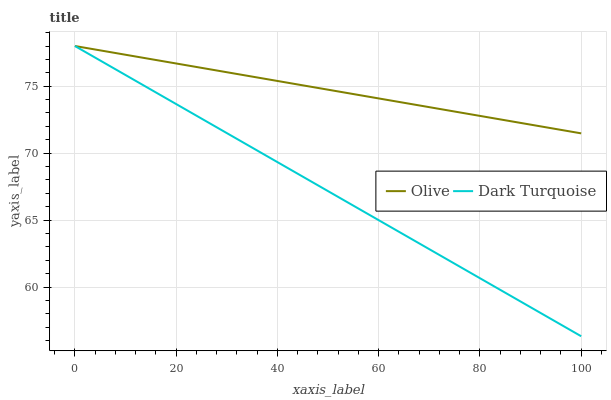Does Dark Turquoise have the minimum area under the curve?
Answer yes or no. Yes. Does Olive have the maximum area under the curve?
Answer yes or no. Yes. Does Dark Turquoise have the maximum area under the curve?
Answer yes or no. No. Is Dark Turquoise the smoothest?
Answer yes or no. Yes. Is Olive the roughest?
Answer yes or no. Yes. Is Dark Turquoise the roughest?
Answer yes or no. No. Does Dark Turquoise have the lowest value?
Answer yes or no. Yes. Does Dark Turquoise have the highest value?
Answer yes or no. Yes. Does Olive intersect Dark Turquoise?
Answer yes or no. Yes. Is Olive less than Dark Turquoise?
Answer yes or no. No. Is Olive greater than Dark Turquoise?
Answer yes or no. No. 